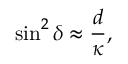Convert formula to latex. <formula><loc_0><loc_0><loc_500><loc_500>\sin ^ { 2 } { \delta } \approx \frac { d } { \kappa } ,</formula> 